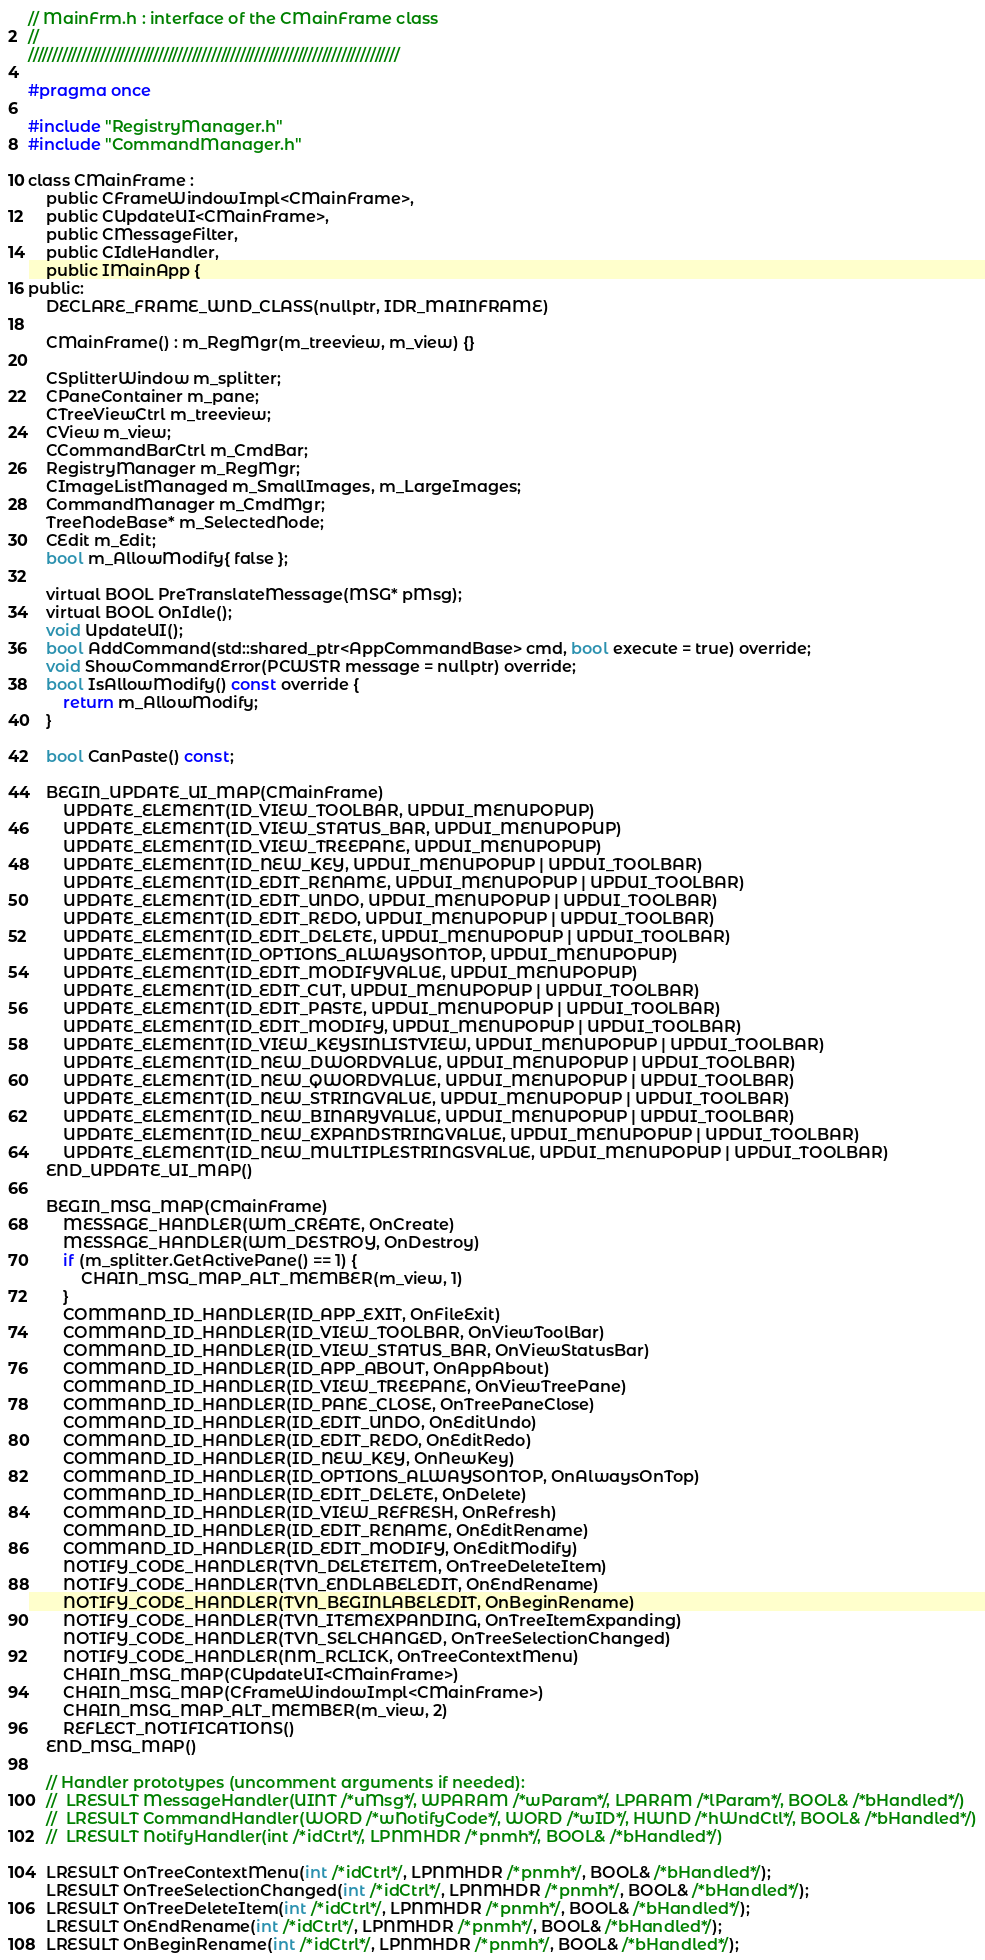Convert code to text. <code><loc_0><loc_0><loc_500><loc_500><_C_>// MainFrm.h : interface of the CMainFrame class
//
/////////////////////////////////////////////////////////////////////////////

#pragma once

#include "RegistryManager.h"
#include "CommandManager.h"

class CMainFrame :
	public CFrameWindowImpl<CMainFrame>,
	public CUpdateUI<CMainFrame>,
	public CMessageFilter, 
	public CIdleHandler,
	public IMainApp {
public:
	DECLARE_FRAME_WND_CLASS(nullptr, IDR_MAINFRAME)

	CMainFrame() : m_RegMgr(m_treeview, m_view) {}

	CSplitterWindow m_splitter;
	CPaneContainer m_pane;
	CTreeViewCtrl m_treeview;
	CView m_view;
	CCommandBarCtrl m_CmdBar;
	RegistryManager m_RegMgr;
	CImageListManaged m_SmallImages, m_LargeImages;
	CommandManager m_CmdMgr;
	TreeNodeBase* m_SelectedNode;
	CEdit m_Edit;
	bool m_AllowModify{ false };

	virtual BOOL PreTranslateMessage(MSG* pMsg);
	virtual BOOL OnIdle();
	void UpdateUI();
	bool AddCommand(std::shared_ptr<AppCommandBase> cmd, bool execute = true) override;
	void ShowCommandError(PCWSTR message = nullptr) override;
	bool IsAllowModify() const override {
		return m_AllowModify;
	}

	bool CanPaste() const;

	BEGIN_UPDATE_UI_MAP(CMainFrame)
		UPDATE_ELEMENT(ID_VIEW_TOOLBAR, UPDUI_MENUPOPUP)
		UPDATE_ELEMENT(ID_VIEW_STATUS_BAR, UPDUI_MENUPOPUP)
		UPDATE_ELEMENT(ID_VIEW_TREEPANE, UPDUI_MENUPOPUP)
		UPDATE_ELEMENT(ID_NEW_KEY, UPDUI_MENUPOPUP | UPDUI_TOOLBAR)
		UPDATE_ELEMENT(ID_EDIT_RENAME, UPDUI_MENUPOPUP | UPDUI_TOOLBAR)
		UPDATE_ELEMENT(ID_EDIT_UNDO, UPDUI_MENUPOPUP | UPDUI_TOOLBAR)
		UPDATE_ELEMENT(ID_EDIT_REDO, UPDUI_MENUPOPUP | UPDUI_TOOLBAR)
		UPDATE_ELEMENT(ID_EDIT_DELETE, UPDUI_MENUPOPUP | UPDUI_TOOLBAR)
		UPDATE_ELEMENT(ID_OPTIONS_ALWAYSONTOP, UPDUI_MENUPOPUP)
		UPDATE_ELEMENT(ID_EDIT_MODIFYVALUE, UPDUI_MENUPOPUP)
		UPDATE_ELEMENT(ID_EDIT_CUT, UPDUI_MENUPOPUP | UPDUI_TOOLBAR)
		UPDATE_ELEMENT(ID_EDIT_PASTE, UPDUI_MENUPOPUP | UPDUI_TOOLBAR)
		UPDATE_ELEMENT(ID_EDIT_MODIFY, UPDUI_MENUPOPUP | UPDUI_TOOLBAR)
		UPDATE_ELEMENT(ID_VIEW_KEYSINLISTVIEW, UPDUI_MENUPOPUP | UPDUI_TOOLBAR)
		UPDATE_ELEMENT(ID_NEW_DWORDVALUE, UPDUI_MENUPOPUP | UPDUI_TOOLBAR)
		UPDATE_ELEMENT(ID_NEW_QWORDVALUE, UPDUI_MENUPOPUP | UPDUI_TOOLBAR)
		UPDATE_ELEMENT(ID_NEW_STRINGVALUE, UPDUI_MENUPOPUP | UPDUI_TOOLBAR)
		UPDATE_ELEMENT(ID_NEW_BINARYVALUE, UPDUI_MENUPOPUP | UPDUI_TOOLBAR)
		UPDATE_ELEMENT(ID_NEW_EXPANDSTRINGVALUE, UPDUI_MENUPOPUP | UPDUI_TOOLBAR)
		UPDATE_ELEMENT(ID_NEW_MULTIPLESTRINGSVALUE, UPDUI_MENUPOPUP | UPDUI_TOOLBAR)
	END_UPDATE_UI_MAP()

	BEGIN_MSG_MAP(CMainFrame)
		MESSAGE_HANDLER(WM_CREATE, OnCreate)
		MESSAGE_HANDLER(WM_DESTROY, OnDestroy)
		if (m_splitter.GetActivePane() == 1) {
			CHAIN_MSG_MAP_ALT_MEMBER(m_view, 1)
		}
		COMMAND_ID_HANDLER(ID_APP_EXIT, OnFileExit)
		COMMAND_ID_HANDLER(ID_VIEW_TOOLBAR, OnViewToolBar)
		COMMAND_ID_HANDLER(ID_VIEW_STATUS_BAR, OnViewStatusBar)
		COMMAND_ID_HANDLER(ID_APP_ABOUT, OnAppAbout)
		COMMAND_ID_HANDLER(ID_VIEW_TREEPANE, OnViewTreePane)
		COMMAND_ID_HANDLER(ID_PANE_CLOSE, OnTreePaneClose)
		COMMAND_ID_HANDLER(ID_EDIT_UNDO, OnEditUndo)
		COMMAND_ID_HANDLER(ID_EDIT_REDO, OnEditRedo)
		COMMAND_ID_HANDLER(ID_NEW_KEY, OnNewKey)
		COMMAND_ID_HANDLER(ID_OPTIONS_ALWAYSONTOP, OnAlwaysOnTop)
		COMMAND_ID_HANDLER(ID_EDIT_DELETE, OnDelete)
		COMMAND_ID_HANDLER(ID_VIEW_REFRESH, OnRefresh)
		COMMAND_ID_HANDLER(ID_EDIT_RENAME, OnEditRename)
		COMMAND_ID_HANDLER(ID_EDIT_MODIFY, OnEditModify)
		NOTIFY_CODE_HANDLER(TVN_DELETEITEM, OnTreeDeleteItem)
		NOTIFY_CODE_HANDLER(TVN_ENDLABELEDIT, OnEndRename)
		NOTIFY_CODE_HANDLER(TVN_BEGINLABELEDIT, OnBeginRename)
		NOTIFY_CODE_HANDLER(TVN_ITEMEXPANDING, OnTreeItemExpanding)
		NOTIFY_CODE_HANDLER(TVN_SELCHANGED, OnTreeSelectionChanged)
		NOTIFY_CODE_HANDLER(NM_RCLICK, OnTreeContextMenu)
		CHAIN_MSG_MAP(CUpdateUI<CMainFrame>)
		CHAIN_MSG_MAP(CFrameWindowImpl<CMainFrame>)
		CHAIN_MSG_MAP_ALT_MEMBER(m_view, 2)
		REFLECT_NOTIFICATIONS()
	END_MSG_MAP()

	// Handler prototypes (uncomment arguments if needed):
	//	LRESULT MessageHandler(UINT /*uMsg*/, WPARAM /*wParam*/, LPARAM /*lParam*/, BOOL& /*bHandled*/)
	//	LRESULT CommandHandler(WORD /*wNotifyCode*/, WORD /*wID*/, HWND /*hWndCtl*/, BOOL& /*bHandled*/)
	//	LRESULT NotifyHandler(int /*idCtrl*/, LPNMHDR /*pnmh*/, BOOL& /*bHandled*/)

	LRESULT OnTreeContextMenu(int /*idCtrl*/, LPNMHDR /*pnmh*/, BOOL& /*bHandled*/);
	LRESULT OnTreeSelectionChanged(int /*idCtrl*/, LPNMHDR /*pnmh*/, BOOL& /*bHandled*/);
	LRESULT OnTreeDeleteItem(int /*idCtrl*/, LPNMHDR /*pnmh*/, BOOL& /*bHandled*/);
	LRESULT OnEndRename(int /*idCtrl*/, LPNMHDR /*pnmh*/, BOOL& /*bHandled*/);
	LRESULT OnBeginRename(int /*idCtrl*/, LPNMHDR /*pnmh*/, BOOL& /*bHandled*/);</code> 